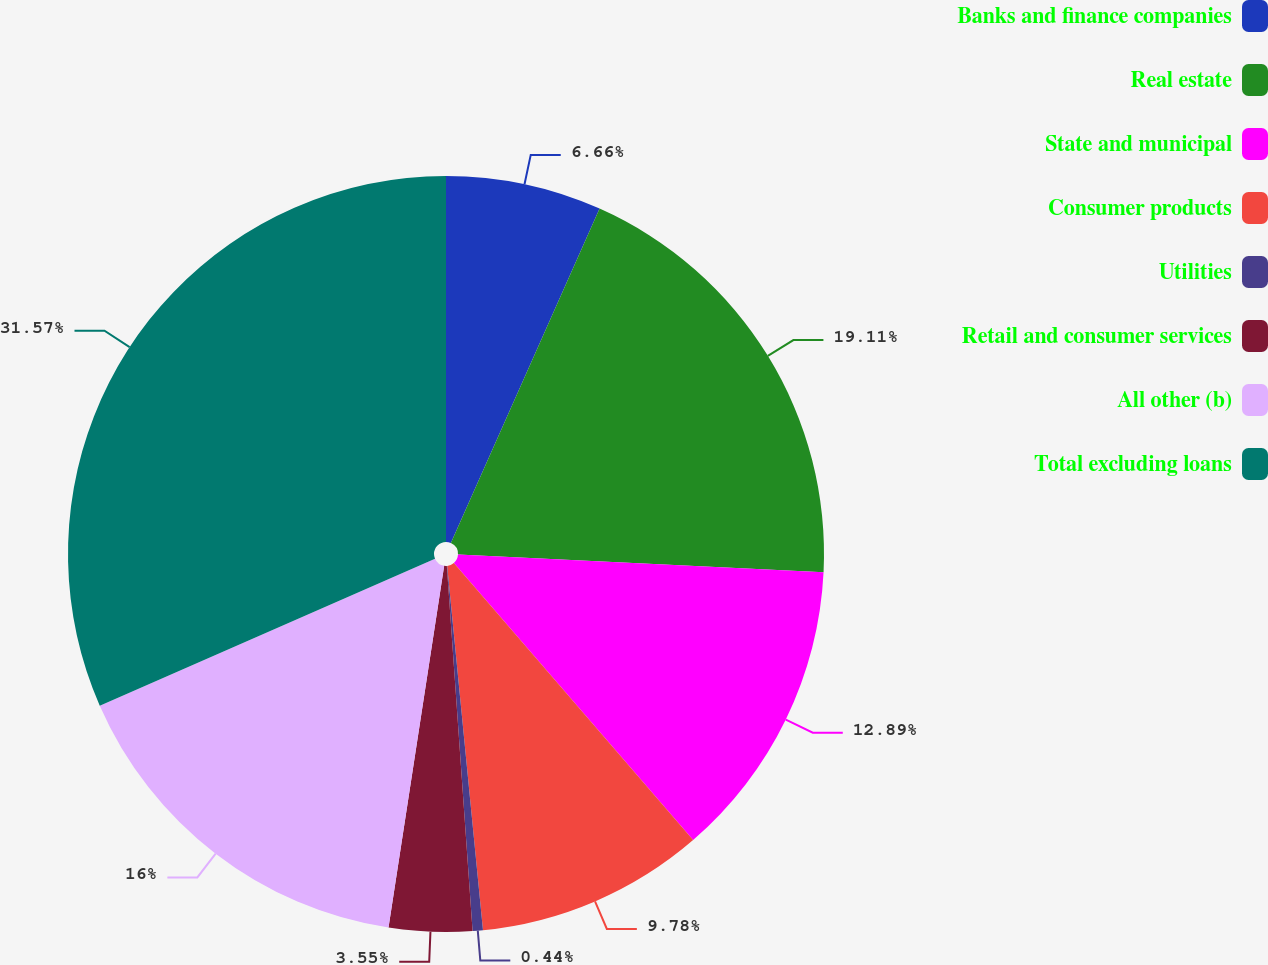Convert chart. <chart><loc_0><loc_0><loc_500><loc_500><pie_chart><fcel>Banks and finance companies<fcel>Real estate<fcel>State and municipal<fcel>Consumer products<fcel>Utilities<fcel>Retail and consumer services<fcel>All other (b)<fcel>Total excluding loans<nl><fcel>6.66%<fcel>19.11%<fcel>12.89%<fcel>9.78%<fcel>0.44%<fcel>3.55%<fcel>16.0%<fcel>31.57%<nl></chart> 